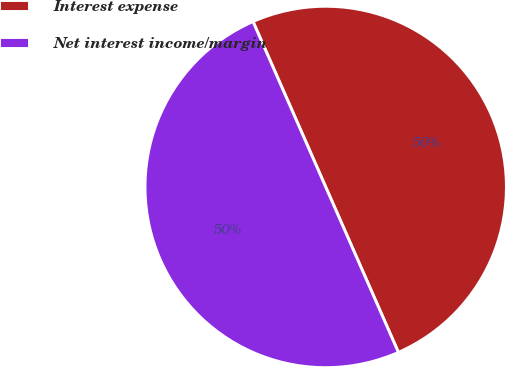Convert chart to OTSL. <chart><loc_0><loc_0><loc_500><loc_500><pie_chart><fcel>Interest expense<fcel>Net interest income/margin<nl><fcel>50.0%<fcel>50.0%<nl></chart> 